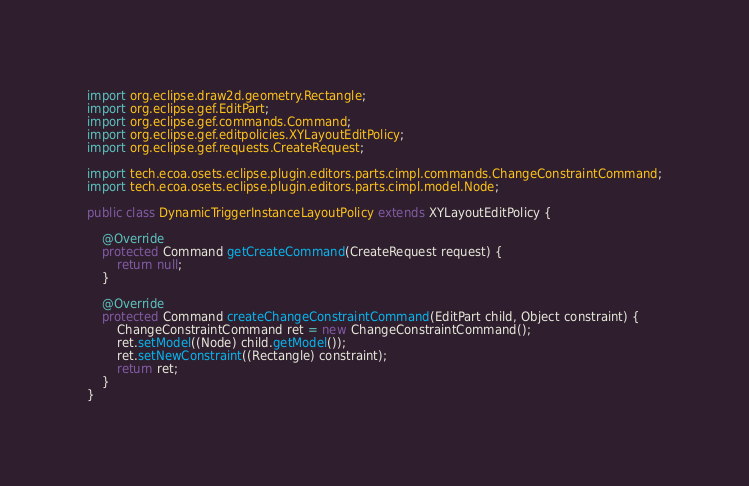Convert code to text. <code><loc_0><loc_0><loc_500><loc_500><_Java_>import org.eclipse.draw2d.geometry.Rectangle;
import org.eclipse.gef.EditPart;
import org.eclipse.gef.commands.Command;
import org.eclipse.gef.editpolicies.XYLayoutEditPolicy;
import org.eclipse.gef.requests.CreateRequest;

import tech.ecoa.osets.eclipse.plugin.editors.parts.cimpl.commands.ChangeConstraintCommand;
import tech.ecoa.osets.eclipse.plugin.editors.parts.cimpl.model.Node;

public class DynamicTriggerInstanceLayoutPolicy extends XYLayoutEditPolicy {

	@Override
	protected Command getCreateCommand(CreateRequest request) {
		return null;
	}

	@Override
	protected Command createChangeConstraintCommand(EditPart child, Object constraint) {
		ChangeConstraintCommand ret = new ChangeConstraintCommand();
		ret.setModel((Node) child.getModel());
		ret.setNewConstraint((Rectangle) constraint);
		return ret;
	}
}
</code> 